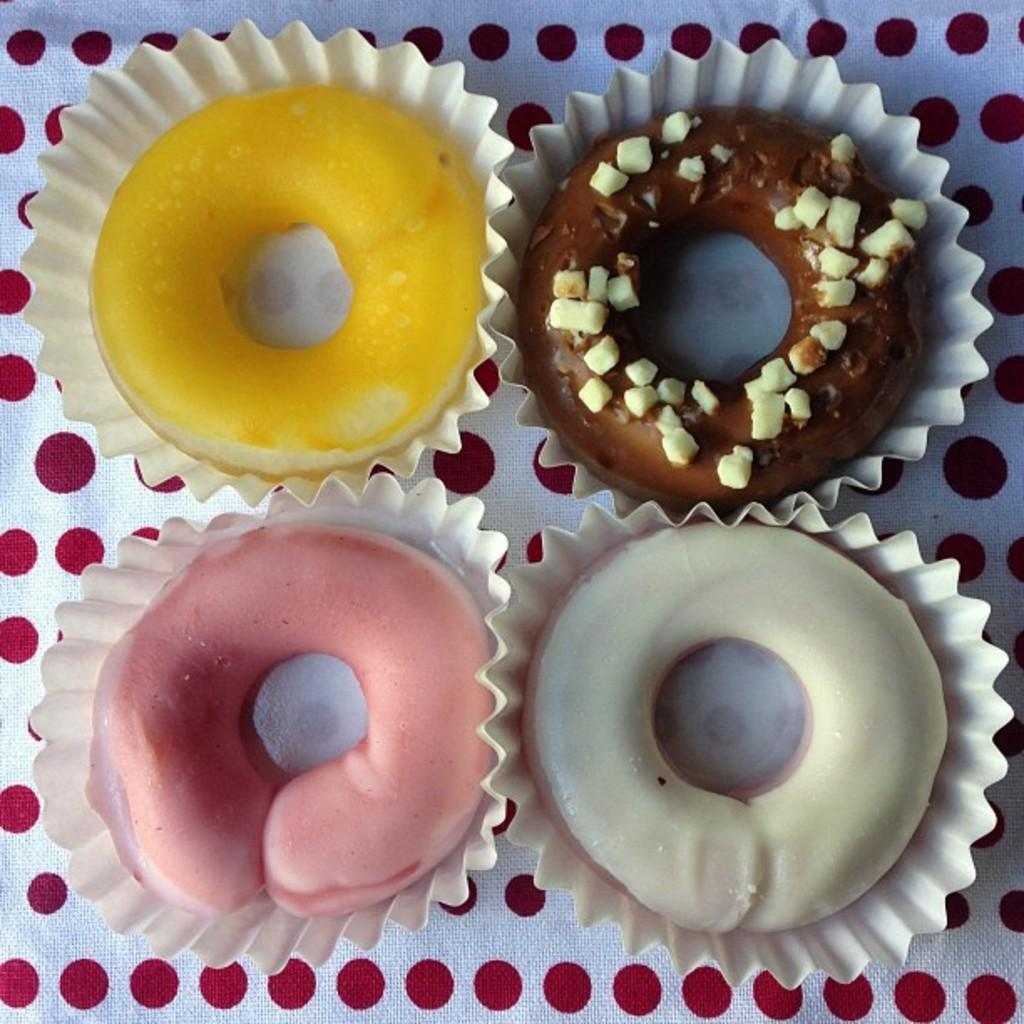What is present in the image related to food? There are food items in the image. How are the food items arranged or contained? The food items are kept in a cloth. Can you describe the colors of the food items? There are four food items with different colors: yellow, pink, white, and brown. What type of dirt can be seen in the image? There is no dirt present in the image; it features food items kept in a cloth. Can you see any yams in the image? There is no yam present in the image. 